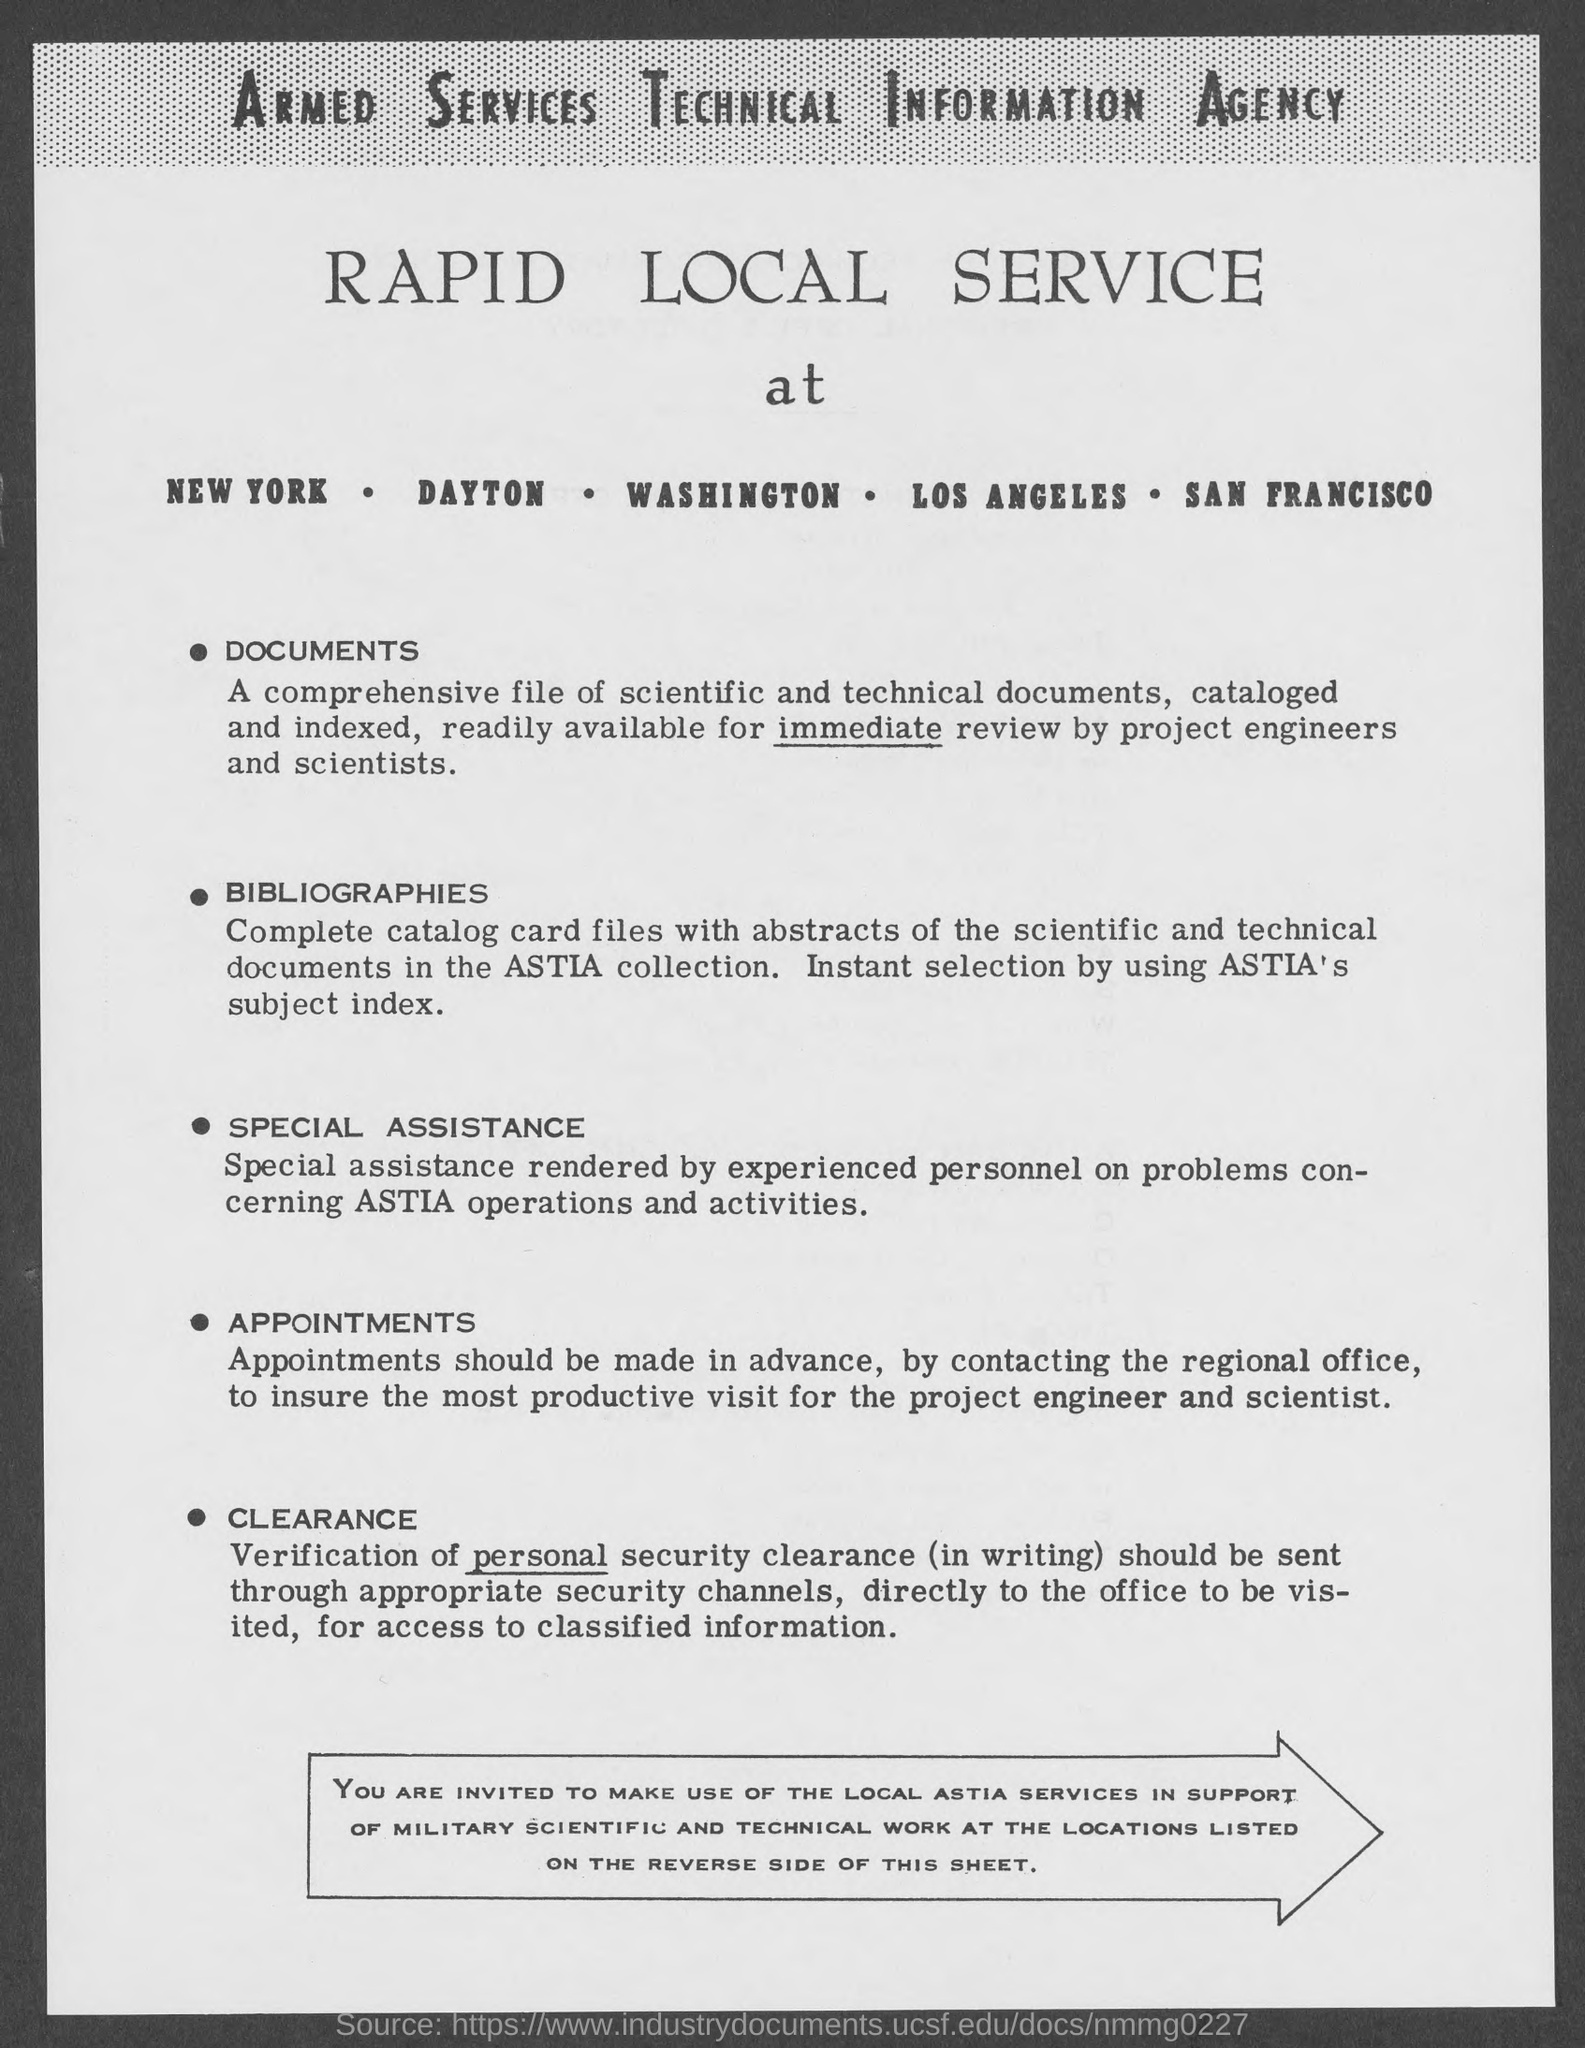Point out several critical features in this image. The Armed Services Technical Information Agency is a government agency responsible for disseminating technical information to the armed forces. 